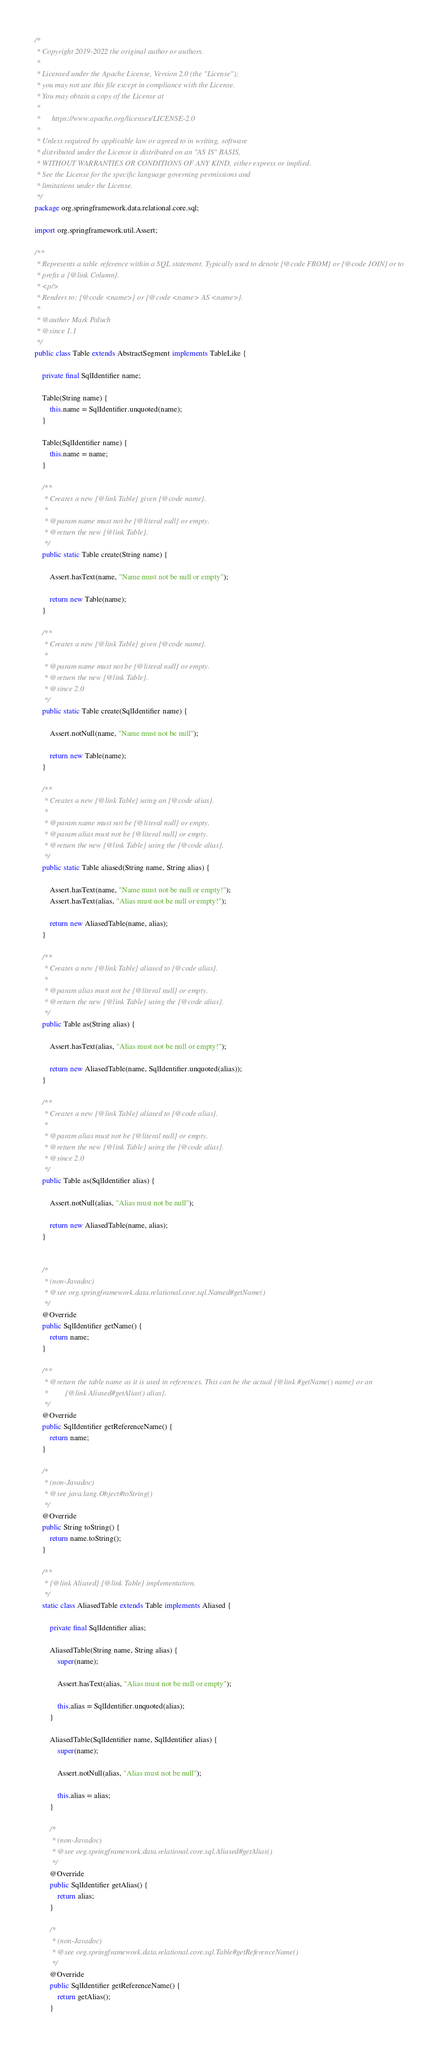<code> <loc_0><loc_0><loc_500><loc_500><_Java_>/*
 * Copyright 2019-2022 the original author or authors.
 *
 * Licensed under the Apache License, Version 2.0 (the "License");
 * you may not use this file except in compliance with the License.
 * You may obtain a copy of the License at
 *
 *      https://www.apache.org/licenses/LICENSE-2.0
 *
 * Unless required by applicable law or agreed to in writing, software
 * distributed under the License is distributed on an "AS IS" BASIS,
 * WITHOUT WARRANTIES OR CONDITIONS OF ANY KIND, either express or implied.
 * See the License for the specific language governing permissions and
 * limitations under the License.
 */
package org.springframework.data.relational.core.sql;

import org.springframework.util.Assert;

/**
 * Represents a table reference within a SQL statement. Typically used to denote {@code FROM} or {@code JOIN} or to
 * prefix a {@link Column}.
 * <p/>
 * Renders to: {@code <name>} or {@code <name> AS <name>}.
 *
 * @author Mark Paluch
 * @since 1.1
 */
public class Table extends AbstractSegment implements TableLike {

	private final SqlIdentifier name;

	Table(String name) {
		this.name = SqlIdentifier.unquoted(name);
	}

	Table(SqlIdentifier name) {
		this.name = name;
	}

	/**
	 * Creates a new {@link Table} given {@code name}.
	 *
	 * @param name must not be {@literal null} or empty.
	 * @return the new {@link Table}.
	 */
	public static Table create(String name) {

		Assert.hasText(name, "Name must not be null or empty");

		return new Table(name);
	}

	/**
	 * Creates a new {@link Table} given {@code name}.
	 *
	 * @param name must not be {@literal null} or empty.
	 * @return the new {@link Table}.
	 * @since 2.0
	 */
	public static Table create(SqlIdentifier name) {

		Assert.notNull(name, "Name must not be null");

		return new Table(name);
	}

	/**
	 * Creates a new {@link Table} using an {@code alias}.
	 *
	 * @param name must not be {@literal null} or empty.
	 * @param alias must not be {@literal null} or empty.
	 * @return the new {@link Table} using the {@code alias}.
	 */
	public static Table aliased(String name, String alias) {

		Assert.hasText(name, "Name must not be null or empty!");
		Assert.hasText(alias, "Alias must not be null or empty!");

		return new AliasedTable(name, alias);
	}

	/**
	 * Creates a new {@link Table} aliased to {@code alias}.
	 *
	 * @param alias must not be {@literal null} or empty.
	 * @return the new {@link Table} using the {@code alias}.
	 */
	public Table as(String alias) {

		Assert.hasText(alias, "Alias must not be null or empty!");

		return new AliasedTable(name, SqlIdentifier.unquoted(alias));
	}

	/**
	 * Creates a new {@link Table} aliased to {@code alias}.
	 *
	 * @param alias must not be {@literal null} or empty.
	 * @return the new {@link Table} using the {@code alias}.
	 * @since 2.0
	 */
	public Table as(SqlIdentifier alias) {

		Assert.notNull(alias, "Alias must not be null");

		return new AliasedTable(name, alias);
	}


	/*
	 * (non-Javadoc)
	 * @see org.springframework.data.relational.core.sql.Named#getName()
	 */
	@Override
	public SqlIdentifier getName() {
		return name;
	}

	/**
	 * @return the table name as it is used in references. This can be the actual {@link #getName() name} or an
	 *         {@link Aliased#getAlias() alias}.
	 */
	@Override
	public SqlIdentifier getReferenceName() {
		return name;
	}

	/*
	 * (non-Javadoc)
	 * @see java.lang.Object#toString()
	 */
	@Override
	public String toString() {
		return name.toString();
	}

	/**
	 * {@link Aliased} {@link Table} implementation.
	 */
	static class AliasedTable extends Table implements Aliased {

		private final SqlIdentifier alias;

		AliasedTable(String name, String alias) {
			super(name);

			Assert.hasText(alias, "Alias must not be null or empty");

			this.alias = SqlIdentifier.unquoted(alias);
		}

		AliasedTable(SqlIdentifier name, SqlIdentifier alias) {
			super(name);

			Assert.notNull(alias, "Alias must not be null");

			this.alias = alias;
		}

		/*
		 * (non-Javadoc)
		 * @see org.springframework.data.relational.core.sql.Aliased#getAlias()
		 */
		@Override
		public SqlIdentifier getAlias() {
			return alias;
		}

		/*
		 * (non-Javadoc)
		 * @see org.springframework.data.relational.core.sql.Table#getReferenceName()
		 */
		@Override
		public SqlIdentifier getReferenceName() {
			return getAlias();
		}
</code> 